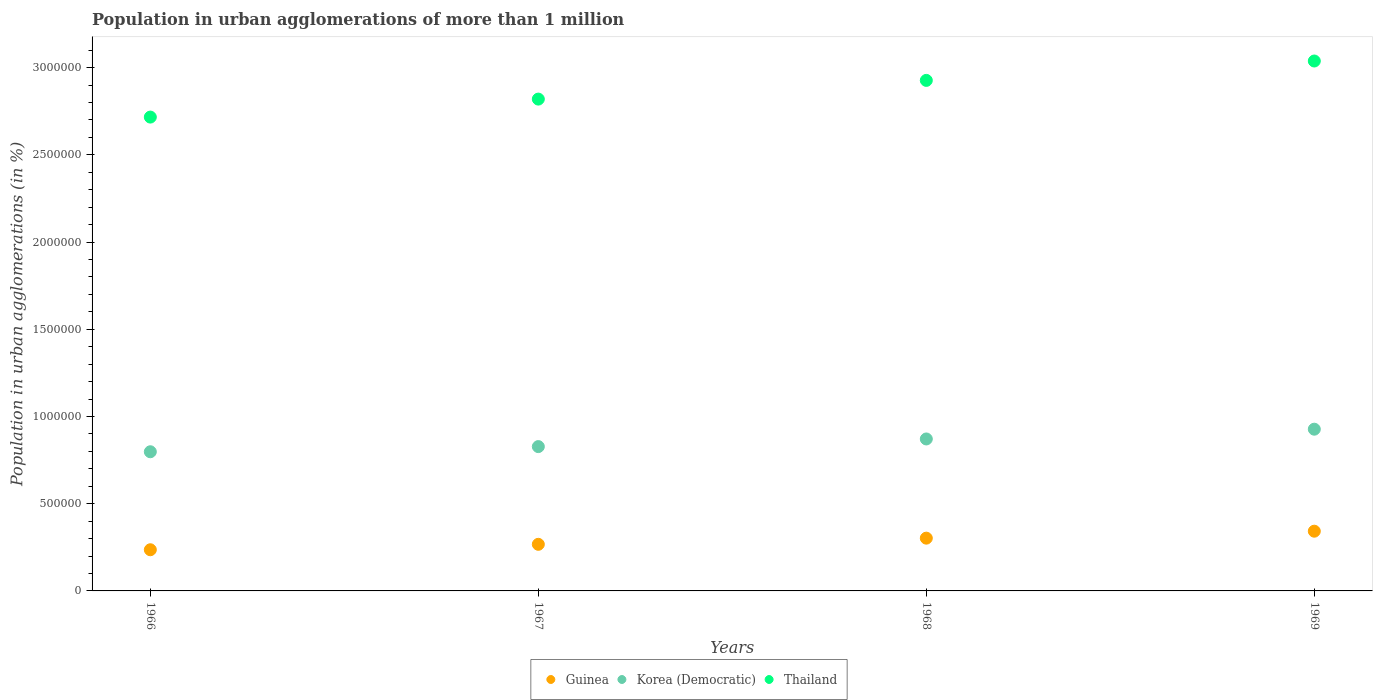How many different coloured dotlines are there?
Your response must be concise. 3. Is the number of dotlines equal to the number of legend labels?
Your answer should be compact. Yes. What is the population in urban agglomerations in Guinea in 1968?
Offer a terse response. 3.02e+05. Across all years, what is the maximum population in urban agglomerations in Korea (Democratic)?
Offer a very short reply. 9.27e+05. Across all years, what is the minimum population in urban agglomerations in Guinea?
Provide a short and direct response. 2.36e+05. In which year was the population in urban agglomerations in Guinea maximum?
Make the answer very short. 1969. In which year was the population in urban agglomerations in Korea (Democratic) minimum?
Your answer should be very brief. 1966. What is the total population in urban agglomerations in Korea (Democratic) in the graph?
Provide a short and direct response. 3.42e+06. What is the difference between the population in urban agglomerations in Thailand in 1967 and that in 1969?
Your response must be concise. -2.18e+05. What is the difference between the population in urban agglomerations in Korea (Democratic) in 1969 and the population in urban agglomerations in Thailand in 1966?
Provide a succinct answer. -1.79e+06. What is the average population in urban agglomerations in Korea (Democratic) per year?
Keep it short and to the point. 8.56e+05. In the year 1968, what is the difference between the population in urban agglomerations in Korea (Democratic) and population in urban agglomerations in Thailand?
Provide a short and direct response. -2.06e+06. What is the ratio of the population in urban agglomerations in Korea (Democratic) in 1966 to that in 1969?
Give a very brief answer. 0.86. What is the difference between the highest and the second highest population in urban agglomerations in Guinea?
Your answer should be compact. 3.99e+04. What is the difference between the highest and the lowest population in urban agglomerations in Thailand?
Make the answer very short. 3.21e+05. In how many years, is the population in urban agglomerations in Guinea greater than the average population in urban agglomerations in Guinea taken over all years?
Your answer should be very brief. 2. Is it the case that in every year, the sum of the population in urban agglomerations in Thailand and population in urban agglomerations in Guinea  is greater than the population in urban agglomerations in Korea (Democratic)?
Provide a short and direct response. Yes. Does the population in urban agglomerations in Korea (Democratic) monotonically increase over the years?
Offer a terse response. Yes. Are the values on the major ticks of Y-axis written in scientific E-notation?
Provide a succinct answer. No. Where does the legend appear in the graph?
Ensure brevity in your answer.  Bottom center. How many legend labels are there?
Your answer should be very brief. 3. How are the legend labels stacked?
Your answer should be compact. Horizontal. What is the title of the graph?
Keep it short and to the point. Population in urban agglomerations of more than 1 million. What is the label or title of the X-axis?
Make the answer very short. Years. What is the label or title of the Y-axis?
Offer a terse response. Population in urban agglomerations (in %). What is the Population in urban agglomerations (in %) in Guinea in 1966?
Your answer should be compact. 2.36e+05. What is the Population in urban agglomerations (in %) of Korea (Democratic) in 1966?
Your response must be concise. 7.98e+05. What is the Population in urban agglomerations (in %) of Thailand in 1966?
Offer a terse response. 2.72e+06. What is the Population in urban agglomerations (in %) in Guinea in 1967?
Offer a terse response. 2.67e+05. What is the Population in urban agglomerations (in %) of Korea (Democratic) in 1967?
Your response must be concise. 8.27e+05. What is the Population in urban agglomerations (in %) of Thailand in 1967?
Your answer should be very brief. 2.82e+06. What is the Population in urban agglomerations (in %) in Guinea in 1968?
Provide a short and direct response. 3.02e+05. What is the Population in urban agglomerations (in %) of Korea (Democratic) in 1968?
Provide a succinct answer. 8.71e+05. What is the Population in urban agglomerations (in %) of Thailand in 1968?
Give a very brief answer. 2.93e+06. What is the Population in urban agglomerations (in %) of Guinea in 1969?
Your answer should be compact. 3.42e+05. What is the Population in urban agglomerations (in %) in Korea (Democratic) in 1969?
Your answer should be very brief. 9.27e+05. What is the Population in urban agglomerations (in %) in Thailand in 1969?
Give a very brief answer. 3.04e+06. Across all years, what is the maximum Population in urban agglomerations (in %) of Guinea?
Keep it short and to the point. 3.42e+05. Across all years, what is the maximum Population in urban agglomerations (in %) of Korea (Democratic)?
Keep it short and to the point. 9.27e+05. Across all years, what is the maximum Population in urban agglomerations (in %) in Thailand?
Make the answer very short. 3.04e+06. Across all years, what is the minimum Population in urban agglomerations (in %) in Guinea?
Offer a terse response. 2.36e+05. Across all years, what is the minimum Population in urban agglomerations (in %) in Korea (Democratic)?
Offer a terse response. 7.98e+05. Across all years, what is the minimum Population in urban agglomerations (in %) of Thailand?
Your answer should be compact. 2.72e+06. What is the total Population in urban agglomerations (in %) in Guinea in the graph?
Your answer should be very brief. 1.15e+06. What is the total Population in urban agglomerations (in %) in Korea (Democratic) in the graph?
Keep it short and to the point. 3.42e+06. What is the total Population in urban agglomerations (in %) of Thailand in the graph?
Provide a succinct answer. 1.15e+07. What is the difference between the Population in urban agglomerations (in %) in Guinea in 1966 and that in 1967?
Keep it short and to the point. -3.12e+04. What is the difference between the Population in urban agglomerations (in %) of Korea (Democratic) in 1966 and that in 1967?
Your answer should be compact. -2.96e+04. What is the difference between the Population in urban agglomerations (in %) in Thailand in 1966 and that in 1967?
Give a very brief answer. -1.03e+05. What is the difference between the Population in urban agglomerations (in %) in Guinea in 1966 and that in 1968?
Offer a terse response. -6.65e+04. What is the difference between the Population in urban agglomerations (in %) of Korea (Democratic) in 1966 and that in 1968?
Offer a terse response. -7.34e+04. What is the difference between the Population in urban agglomerations (in %) of Thailand in 1966 and that in 1968?
Your response must be concise. -2.10e+05. What is the difference between the Population in urban agglomerations (in %) of Guinea in 1966 and that in 1969?
Your response must be concise. -1.06e+05. What is the difference between the Population in urban agglomerations (in %) of Korea (Democratic) in 1966 and that in 1969?
Give a very brief answer. -1.29e+05. What is the difference between the Population in urban agglomerations (in %) of Thailand in 1966 and that in 1969?
Your response must be concise. -3.21e+05. What is the difference between the Population in urban agglomerations (in %) in Guinea in 1967 and that in 1968?
Offer a terse response. -3.53e+04. What is the difference between the Population in urban agglomerations (in %) in Korea (Democratic) in 1967 and that in 1968?
Your response must be concise. -4.38e+04. What is the difference between the Population in urban agglomerations (in %) in Thailand in 1967 and that in 1968?
Your answer should be compact. -1.07e+05. What is the difference between the Population in urban agglomerations (in %) of Guinea in 1967 and that in 1969?
Provide a short and direct response. -7.52e+04. What is the difference between the Population in urban agglomerations (in %) in Korea (Democratic) in 1967 and that in 1969?
Your response must be concise. -9.98e+04. What is the difference between the Population in urban agglomerations (in %) of Thailand in 1967 and that in 1969?
Make the answer very short. -2.18e+05. What is the difference between the Population in urban agglomerations (in %) in Guinea in 1968 and that in 1969?
Keep it short and to the point. -3.99e+04. What is the difference between the Population in urban agglomerations (in %) of Korea (Democratic) in 1968 and that in 1969?
Give a very brief answer. -5.60e+04. What is the difference between the Population in urban agglomerations (in %) of Thailand in 1968 and that in 1969?
Your answer should be compact. -1.11e+05. What is the difference between the Population in urban agglomerations (in %) of Guinea in 1966 and the Population in urban agglomerations (in %) of Korea (Democratic) in 1967?
Provide a succinct answer. -5.91e+05. What is the difference between the Population in urban agglomerations (in %) of Guinea in 1966 and the Population in urban agglomerations (in %) of Thailand in 1967?
Offer a very short reply. -2.58e+06. What is the difference between the Population in urban agglomerations (in %) in Korea (Democratic) in 1966 and the Population in urban agglomerations (in %) in Thailand in 1967?
Your response must be concise. -2.02e+06. What is the difference between the Population in urban agglomerations (in %) of Guinea in 1966 and the Population in urban agglomerations (in %) of Korea (Democratic) in 1968?
Ensure brevity in your answer.  -6.35e+05. What is the difference between the Population in urban agglomerations (in %) in Guinea in 1966 and the Population in urban agglomerations (in %) in Thailand in 1968?
Your answer should be compact. -2.69e+06. What is the difference between the Population in urban agglomerations (in %) in Korea (Democratic) in 1966 and the Population in urban agglomerations (in %) in Thailand in 1968?
Your response must be concise. -2.13e+06. What is the difference between the Population in urban agglomerations (in %) of Guinea in 1966 and the Population in urban agglomerations (in %) of Korea (Democratic) in 1969?
Make the answer very short. -6.91e+05. What is the difference between the Population in urban agglomerations (in %) in Guinea in 1966 and the Population in urban agglomerations (in %) in Thailand in 1969?
Your response must be concise. -2.80e+06. What is the difference between the Population in urban agglomerations (in %) in Korea (Democratic) in 1966 and the Population in urban agglomerations (in %) in Thailand in 1969?
Your answer should be very brief. -2.24e+06. What is the difference between the Population in urban agglomerations (in %) of Guinea in 1967 and the Population in urban agglomerations (in %) of Korea (Democratic) in 1968?
Offer a very short reply. -6.04e+05. What is the difference between the Population in urban agglomerations (in %) in Guinea in 1967 and the Population in urban agglomerations (in %) in Thailand in 1968?
Your response must be concise. -2.66e+06. What is the difference between the Population in urban agglomerations (in %) of Korea (Democratic) in 1967 and the Population in urban agglomerations (in %) of Thailand in 1968?
Make the answer very short. -2.10e+06. What is the difference between the Population in urban agglomerations (in %) in Guinea in 1967 and the Population in urban agglomerations (in %) in Korea (Democratic) in 1969?
Offer a very short reply. -6.60e+05. What is the difference between the Population in urban agglomerations (in %) in Guinea in 1967 and the Population in urban agglomerations (in %) in Thailand in 1969?
Your answer should be compact. -2.77e+06. What is the difference between the Population in urban agglomerations (in %) of Korea (Democratic) in 1967 and the Population in urban agglomerations (in %) of Thailand in 1969?
Keep it short and to the point. -2.21e+06. What is the difference between the Population in urban agglomerations (in %) of Guinea in 1968 and the Population in urban agglomerations (in %) of Korea (Democratic) in 1969?
Ensure brevity in your answer.  -6.25e+05. What is the difference between the Population in urban agglomerations (in %) in Guinea in 1968 and the Population in urban agglomerations (in %) in Thailand in 1969?
Offer a terse response. -2.74e+06. What is the difference between the Population in urban agglomerations (in %) of Korea (Democratic) in 1968 and the Population in urban agglomerations (in %) of Thailand in 1969?
Offer a very short reply. -2.17e+06. What is the average Population in urban agglomerations (in %) of Guinea per year?
Provide a succinct answer. 2.87e+05. What is the average Population in urban agglomerations (in %) of Korea (Democratic) per year?
Offer a terse response. 8.56e+05. What is the average Population in urban agglomerations (in %) of Thailand per year?
Your answer should be compact. 2.87e+06. In the year 1966, what is the difference between the Population in urban agglomerations (in %) in Guinea and Population in urban agglomerations (in %) in Korea (Democratic)?
Make the answer very short. -5.62e+05. In the year 1966, what is the difference between the Population in urban agglomerations (in %) in Guinea and Population in urban agglomerations (in %) in Thailand?
Provide a succinct answer. -2.48e+06. In the year 1966, what is the difference between the Population in urban agglomerations (in %) in Korea (Democratic) and Population in urban agglomerations (in %) in Thailand?
Your answer should be very brief. -1.92e+06. In the year 1967, what is the difference between the Population in urban agglomerations (in %) in Guinea and Population in urban agglomerations (in %) in Korea (Democratic)?
Keep it short and to the point. -5.60e+05. In the year 1967, what is the difference between the Population in urban agglomerations (in %) of Guinea and Population in urban agglomerations (in %) of Thailand?
Ensure brevity in your answer.  -2.55e+06. In the year 1967, what is the difference between the Population in urban agglomerations (in %) in Korea (Democratic) and Population in urban agglomerations (in %) in Thailand?
Provide a short and direct response. -1.99e+06. In the year 1968, what is the difference between the Population in urban agglomerations (in %) of Guinea and Population in urban agglomerations (in %) of Korea (Democratic)?
Your answer should be very brief. -5.69e+05. In the year 1968, what is the difference between the Population in urban agglomerations (in %) of Guinea and Population in urban agglomerations (in %) of Thailand?
Keep it short and to the point. -2.62e+06. In the year 1968, what is the difference between the Population in urban agglomerations (in %) of Korea (Democratic) and Population in urban agglomerations (in %) of Thailand?
Keep it short and to the point. -2.06e+06. In the year 1969, what is the difference between the Population in urban agglomerations (in %) of Guinea and Population in urban agglomerations (in %) of Korea (Democratic)?
Ensure brevity in your answer.  -5.85e+05. In the year 1969, what is the difference between the Population in urban agglomerations (in %) in Guinea and Population in urban agglomerations (in %) in Thailand?
Ensure brevity in your answer.  -2.70e+06. In the year 1969, what is the difference between the Population in urban agglomerations (in %) of Korea (Democratic) and Population in urban agglomerations (in %) of Thailand?
Offer a terse response. -2.11e+06. What is the ratio of the Population in urban agglomerations (in %) of Guinea in 1966 to that in 1967?
Offer a very short reply. 0.88. What is the ratio of the Population in urban agglomerations (in %) of Thailand in 1966 to that in 1967?
Ensure brevity in your answer.  0.96. What is the ratio of the Population in urban agglomerations (in %) in Guinea in 1966 to that in 1968?
Provide a succinct answer. 0.78. What is the ratio of the Population in urban agglomerations (in %) of Korea (Democratic) in 1966 to that in 1968?
Provide a short and direct response. 0.92. What is the ratio of the Population in urban agglomerations (in %) in Thailand in 1966 to that in 1968?
Ensure brevity in your answer.  0.93. What is the ratio of the Population in urban agglomerations (in %) of Guinea in 1966 to that in 1969?
Ensure brevity in your answer.  0.69. What is the ratio of the Population in urban agglomerations (in %) of Korea (Democratic) in 1966 to that in 1969?
Offer a terse response. 0.86. What is the ratio of the Population in urban agglomerations (in %) in Thailand in 1966 to that in 1969?
Offer a terse response. 0.89. What is the ratio of the Population in urban agglomerations (in %) of Guinea in 1967 to that in 1968?
Provide a succinct answer. 0.88. What is the ratio of the Population in urban agglomerations (in %) of Korea (Democratic) in 1967 to that in 1968?
Offer a terse response. 0.95. What is the ratio of the Population in urban agglomerations (in %) in Thailand in 1967 to that in 1968?
Keep it short and to the point. 0.96. What is the ratio of the Population in urban agglomerations (in %) in Guinea in 1967 to that in 1969?
Your answer should be very brief. 0.78. What is the ratio of the Population in urban agglomerations (in %) in Korea (Democratic) in 1967 to that in 1969?
Your answer should be compact. 0.89. What is the ratio of the Population in urban agglomerations (in %) in Thailand in 1967 to that in 1969?
Provide a short and direct response. 0.93. What is the ratio of the Population in urban agglomerations (in %) of Guinea in 1968 to that in 1969?
Provide a succinct answer. 0.88. What is the ratio of the Population in urban agglomerations (in %) in Korea (Democratic) in 1968 to that in 1969?
Your answer should be very brief. 0.94. What is the ratio of the Population in urban agglomerations (in %) in Thailand in 1968 to that in 1969?
Your response must be concise. 0.96. What is the difference between the highest and the second highest Population in urban agglomerations (in %) of Guinea?
Make the answer very short. 3.99e+04. What is the difference between the highest and the second highest Population in urban agglomerations (in %) of Korea (Democratic)?
Ensure brevity in your answer.  5.60e+04. What is the difference between the highest and the second highest Population in urban agglomerations (in %) in Thailand?
Ensure brevity in your answer.  1.11e+05. What is the difference between the highest and the lowest Population in urban agglomerations (in %) in Guinea?
Your response must be concise. 1.06e+05. What is the difference between the highest and the lowest Population in urban agglomerations (in %) of Korea (Democratic)?
Offer a terse response. 1.29e+05. What is the difference between the highest and the lowest Population in urban agglomerations (in %) of Thailand?
Your answer should be very brief. 3.21e+05. 